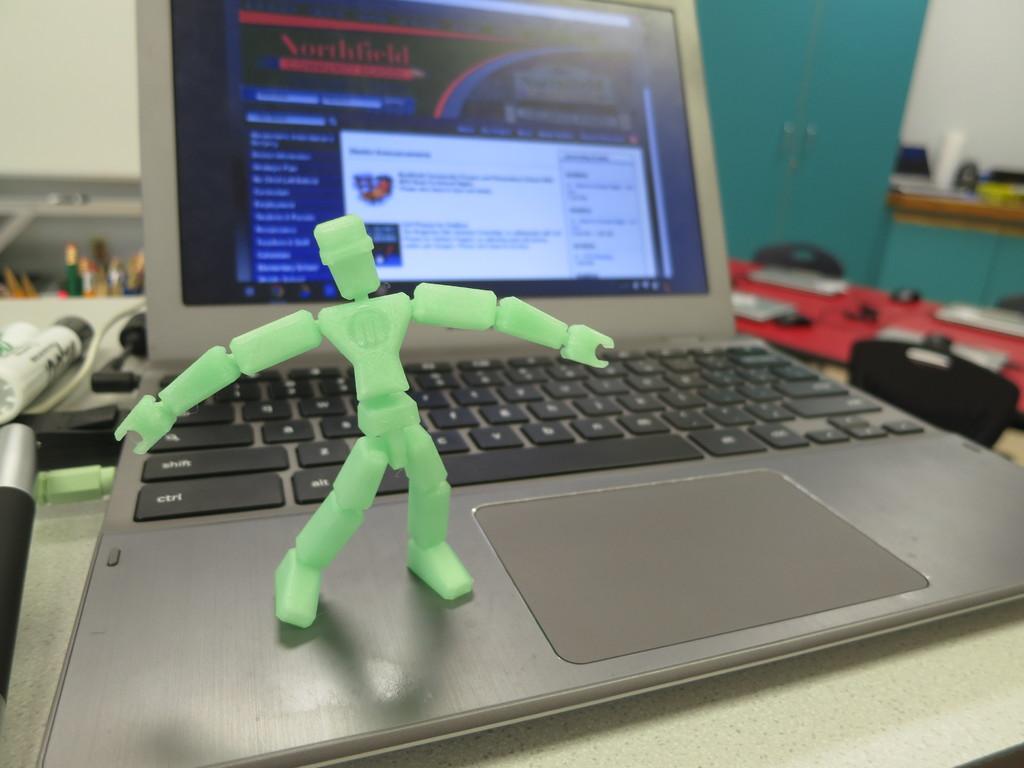Does the keyboard have a ctrl key?
Make the answer very short. Yes. 